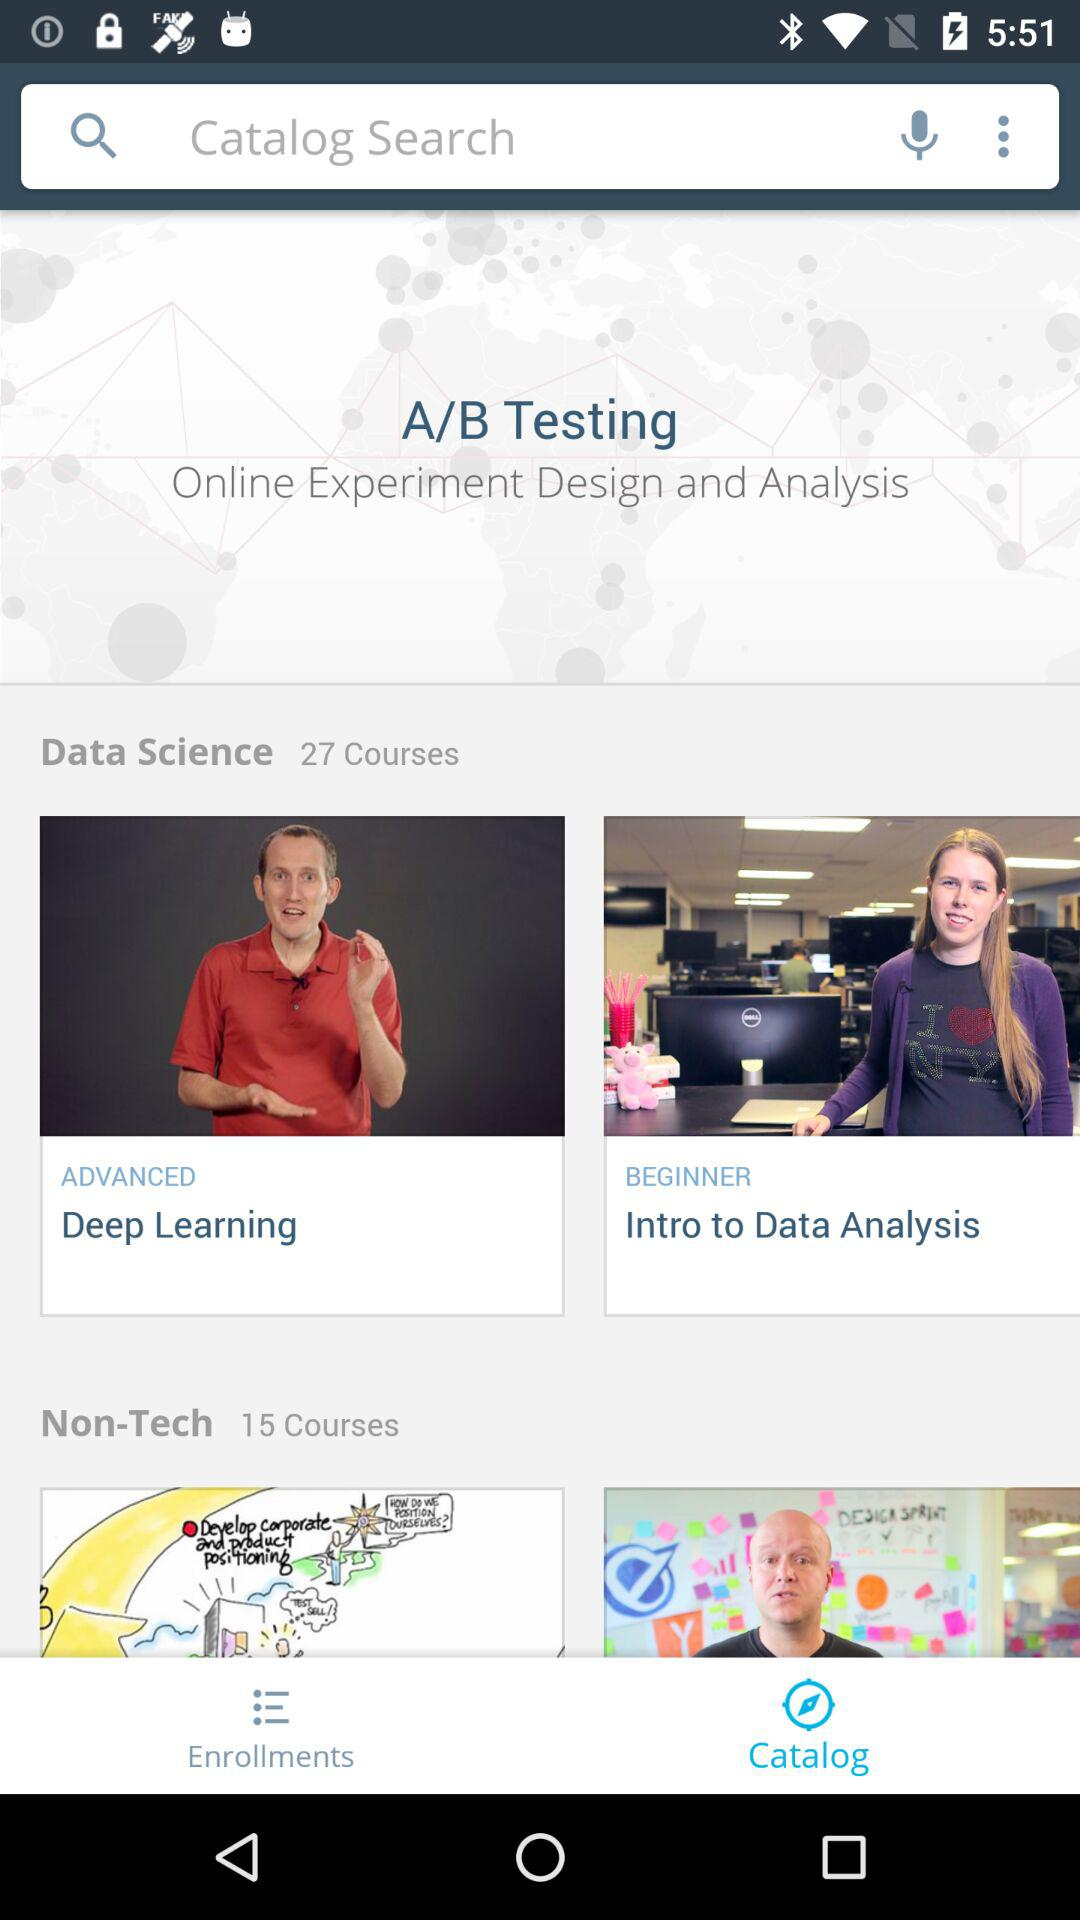How many courses in total are there in "Data Science"? There are 27 courses in "Data Science". 